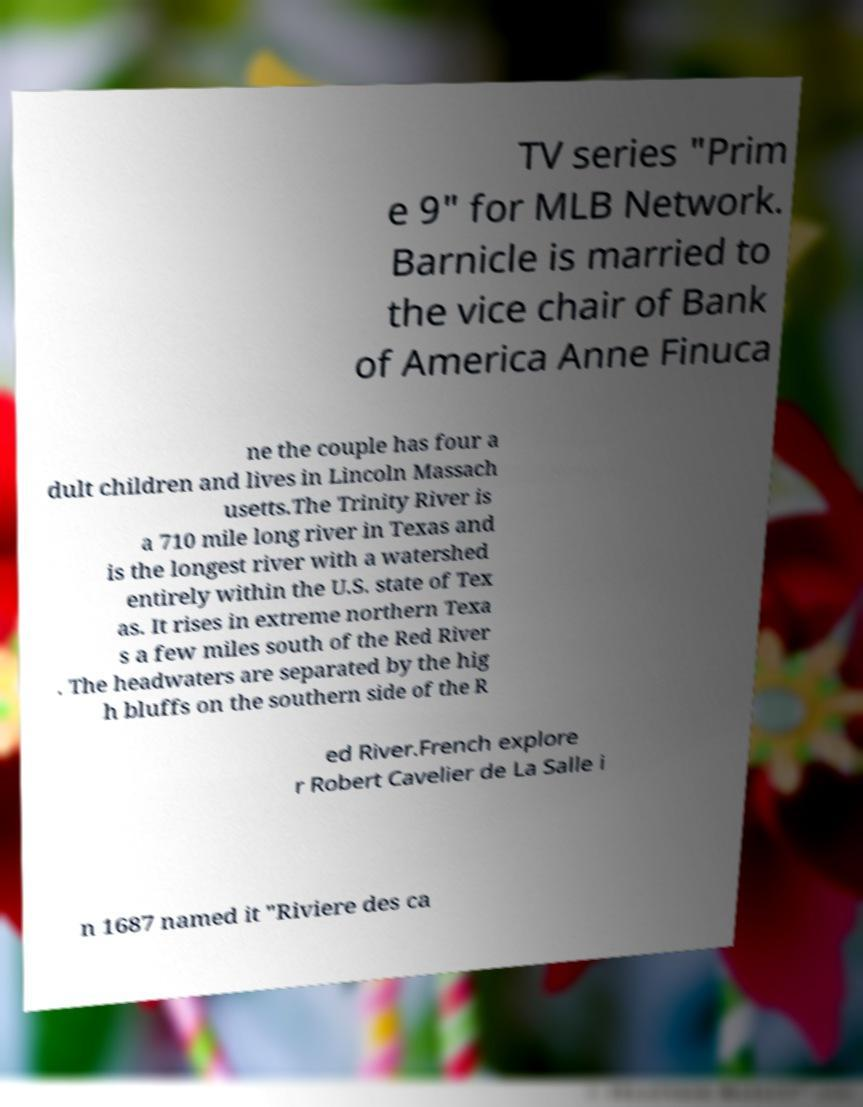For documentation purposes, I need the text within this image transcribed. Could you provide that? TV series "Prim e 9" for MLB Network. Barnicle is married to the vice chair of Bank of America Anne Finuca ne the couple has four a dult children and lives in Lincoln Massach usetts.The Trinity River is a 710 mile long river in Texas and is the longest river with a watershed entirely within the U.S. state of Tex as. It rises in extreme northern Texa s a few miles south of the Red River . The headwaters are separated by the hig h bluffs on the southern side of the R ed River.French explore r Robert Cavelier de La Salle i n 1687 named it "Riviere des ca 